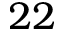Convert formula to latex. <formula><loc_0><loc_0><loc_500><loc_500>2 2</formula> 